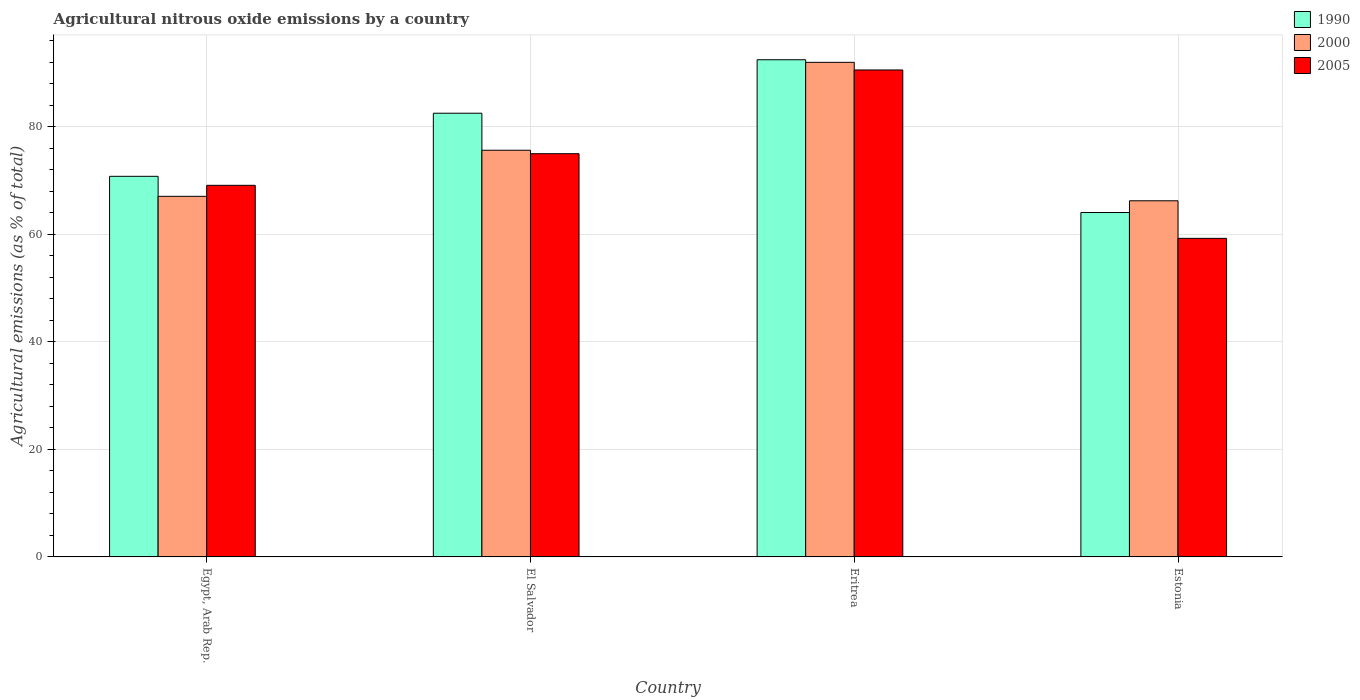How many groups of bars are there?
Provide a short and direct response. 4. Are the number of bars per tick equal to the number of legend labels?
Make the answer very short. Yes. Are the number of bars on each tick of the X-axis equal?
Offer a very short reply. Yes. How many bars are there on the 1st tick from the right?
Offer a very short reply. 3. What is the label of the 4th group of bars from the left?
Make the answer very short. Estonia. What is the amount of agricultural nitrous oxide emitted in 1990 in Estonia?
Your response must be concise. 64.06. Across all countries, what is the maximum amount of agricultural nitrous oxide emitted in 2005?
Ensure brevity in your answer.  90.57. Across all countries, what is the minimum amount of agricultural nitrous oxide emitted in 1990?
Keep it short and to the point. 64.06. In which country was the amount of agricultural nitrous oxide emitted in 2000 maximum?
Give a very brief answer. Eritrea. In which country was the amount of agricultural nitrous oxide emitted in 1990 minimum?
Ensure brevity in your answer.  Estonia. What is the total amount of agricultural nitrous oxide emitted in 2000 in the graph?
Make the answer very short. 300.93. What is the difference between the amount of agricultural nitrous oxide emitted in 1990 in Eritrea and that in Estonia?
Give a very brief answer. 28.41. What is the difference between the amount of agricultural nitrous oxide emitted in 2000 in Eritrea and the amount of agricultural nitrous oxide emitted in 1990 in Estonia?
Your answer should be compact. 27.93. What is the average amount of agricultural nitrous oxide emitted in 2000 per country?
Keep it short and to the point. 75.23. What is the difference between the amount of agricultural nitrous oxide emitted of/in 2000 and amount of agricultural nitrous oxide emitted of/in 1990 in Estonia?
Offer a very short reply. 2.18. In how many countries, is the amount of agricultural nitrous oxide emitted in 1990 greater than 56 %?
Offer a terse response. 4. What is the ratio of the amount of agricultural nitrous oxide emitted in 2005 in Egypt, Arab Rep. to that in Estonia?
Your response must be concise. 1.17. Is the difference between the amount of agricultural nitrous oxide emitted in 2000 in Egypt, Arab Rep. and Estonia greater than the difference between the amount of agricultural nitrous oxide emitted in 1990 in Egypt, Arab Rep. and Estonia?
Give a very brief answer. No. What is the difference between the highest and the second highest amount of agricultural nitrous oxide emitted in 1990?
Ensure brevity in your answer.  -9.95. What is the difference between the highest and the lowest amount of agricultural nitrous oxide emitted in 1990?
Offer a terse response. 28.41. What does the 2nd bar from the right in Eritrea represents?
Make the answer very short. 2000. How many bars are there?
Make the answer very short. 12. Are all the bars in the graph horizontal?
Give a very brief answer. No. How many countries are there in the graph?
Your response must be concise. 4. What is the difference between two consecutive major ticks on the Y-axis?
Keep it short and to the point. 20. How many legend labels are there?
Your answer should be very brief. 3. What is the title of the graph?
Your response must be concise. Agricultural nitrous oxide emissions by a country. What is the label or title of the X-axis?
Keep it short and to the point. Country. What is the label or title of the Y-axis?
Keep it short and to the point. Agricultural emissions (as % of total). What is the Agricultural emissions (as % of total) in 1990 in Egypt, Arab Rep.?
Give a very brief answer. 70.79. What is the Agricultural emissions (as % of total) of 2000 in Egypt, Arab Rep.?
Make the answer very short. 67.07. What is the Agricultural emissions (as % of total) in 2005 in Egypt, Arab Rep.?
Ensure brevity in your answer.  69.11. What is the Agricultural emissions (as % of total) in 1990 in El Salvador?
Give a very brief answer. 82.52. What is the Agricultural emissions (as % of total) of 2000 in El Salvador?
Ensure brevity in your answer.  75.64. What is the Agricultural emissions (as % of total) of 2005 in El Salvador?
Provide a short and direct response. 74.99. What is the Agricultural emissions (as % of total) in 1990 in Eritrea?
Keep it short and to the point. 92.47. What is the Agricultural emissions (as % of total) of 2000 in Eritrea?
Offer a terse response. 91.99. What is the Agricultural emissions (as % of total) of 2005 in Eritrea?
Provide a succinct answer. 90.57. What is the Agricultural emissions (as % of total) in 1990 in Estonia?
Give a very brief answer. 64.06. What is the Agricultural emissions (as % of total) in 2000 in Estonia?
Ensure brevity in your answer.  66.24. What is the Agricultural emissions (as % of total) of 2005 in Estonia?
Your answer should be compact. 59.25. Across all countries, what is the maximum Agricultural emissions (as % of total) in 1990?
Give a very brief answer. 92.47. Across all countries, what is the maximum Agricultural emissions (as % of total) of 2000?
Your answer should be compact. 91.99. Across all countries, what is the maximum Agricultural emissions (as % of total) of 2005?
Provide a succinct answer. 90.57. Across all countries, what is the minimum Agricultural emissions (as % of total) in 1990?
Provide a short and direct response. 64.06. Across all countries, what is the minimum Agricultural emissions (as % of total) of 2000?
Make the answer very short. 66.24. Across all countries, what is the minimum Agricultural emissions (as % of total) of 2005?
Ensure brevity in your answer.  59.25. What is the total Agricultural emissions (as % of total) in 1990 in the graph?
Provide a short and direct response. 309.84. What is the total Agricultural emissions (as % of total) in 2000 in the graph?
Provide a succinct answer. 300.93. What is the total Agricultural emissions (as % of total) of 2005 in the graph?
Provide a short and direct response. 293.93. What is the difference between the Agricultural emissions (as % of total) of 1990 in Egypt, Arab Rep. and that in El Salvador?
Your answer should be very brief. -11.73. What is the difference between the Agricultural emissions (as % of total) in 2000 in Egypt, Arab Rep. and that in El Salvador?
Provide a succinct answer. -8.57. What is the difference between the Agricultural emissions (as % of total) in 2005 in Egypt, Arab Rep. and that in El Salvador?
Your response must be concise. -5.88. What is the difference between the Agricultural emissions (as % of total) of 1990 in Egypt, Arab Rep. and that in Eritrea?
Your response must be concise. -21.68. What is the difference between the Agricultural emissions (as % of total) of 2000 in Egypt, Arab Rep. and that in Eritrea?
Your response must be concise. -24.92. What is the difference between the Agricultural emissions (as % of total) of 2005 in Egypt, Arab Rep. and that in Eritrea?
Offer a terse response. -21.46. What is the difference between the Agricultural emissions (as % of total) in 1990 in Egypt, Arab Rep. and that in Estonia?
Your answer should be compact. 6.73. What is the difference between the Agricultural emissions (as % of total) of 2000 in Egypt, Arab Rep. and that in Estonia?
Ensure brevity in your answer.  0.83. What is the difference between the Agricultural emissions (as % of total) of 2005 in Egypt, Arab Rep. and that in Estonia?
Your response must be concise. 9.86. What is the difference between the Agricultural emissions (as % of total) of 1990 in El Salvador and that in Eritrea?
Keep it short and to the point. -9.95. What is the difference between the Agricultural emissions (as % of total) in 2000 in El Salvador and that in Eritrea?
Provide a short and direct response. -16.35. What is the difference between the Agricultural emissions (as % of total) of 2005 in El Salvador and that in Eritrea?
Your answer should be very brief. -15.57. What is the difference between the Agricultural emissions (as % of total) in 1990 in El Salvador and that in Estonia?
Give a very brief answer. 18.47. What is the difference between the Agricultural emissions (as % of total) of 2000 in El Salvador and that in Estonia?
Provide a short and direct response. 9.4. What is the difference between the Agricultural emissions (as % of total) in 2005 in El Salvador and that in Estonia?
Ensure brevity in your answer.  15.74. What is the difference between the Agricultural emissions (as % of total) in 1990 in Eritrea and that in Estonia?
Give a very brief answer. 28.41. What is the difference between the Agricultural emissions (as % of total) in 2000 in Eritrea and that in Estonia?
Offer a very short reply. 25.75. What is the difference between the Agricultural emissions (as % of total) in 2005 in Eritrea and that in Estonia?
Your answer should be compact. 31.32. What is the difference between the Agricultural emissions (as % of total) of 1990 in Egypt, Arab Rep. and the Agricultural emissions (as % of total) of 2000 in El Salvador?
Your answer should be very brief. -4.85. What is the difference between the Agricultural emissions (as % of total) in 1990 in Egypt, Arab Rep. and the Agricultural emissions (as % of total) in 2005 in El Salvador?
Your answer should be compact. -4.21. What is the difference between the Agricultural emissions (as % of total) in 2000 in Egypt, Arab Rep. and the Agricultural emissions (as % of total) in 2005 in El Salvador?
Ensure brevity in your answer.  -7.93. What is the difference between the Agricultural emissions (as % of total) in 1990 in Egypt, Arab Rep. and the Agricultural emissions (as % of total) in 2000 in Eritrea?
Offer a terse response. -21.2. What is the difference between the Agricultural emissions (as % of total) in 1990 in Egypt, Arab Rep. and the Agricultural emissions (as % of total) in 2005 in Eritrea?
Your answer should be very brief. -19.78. What is the difference between the Agricultural emissions (as % of total) of 2000 in Egypt, Arab Rep. and the Agricultural emissions (as % of total) of 2005 in Eritrea?
Keep it short and to the point. -23.5. What is the difference between the Agricultural emissions (as % of total) in 1990 in Egypt, Arab Rep. and the Agricultural emissions (as % of total) in 2000 in Estonia?
Your answer should be compact. 4.55. What is the difference between the Agricultural emissions (as % of total) of 1990 in Egypt, Arab Rep. and the Agricultural emissions (as % of total) of 2005 in Estonia?
Ensure brevity in your answer.  11.54. What is the difference between the Agricultural emissions (as % of total) in 2000 in Egypt, Arab Rep. and the Agricultural emissions (as % of total) in 2005 in Estonia?
Your response must be concise. 7.82. What is the difference between the Agricultural emissions (as % of total) of 1990 in El Salvador and the Agricultural emissions (as % of total) of 2000 in Eritrea?
Offer a terse response. -9.46. What is the difference between the Agricultural emissions (as % of total) in 1990 in El Salvador and the Agricultural emissions (as % of total) in 2005 in Eritrea?
Offer a very short reply. -8.05. What is the difference between the Agricultural emissions (as % of total) of 2000 in El Salvador and the Agricultural emissions (as % of total) of 2005 in Eritrea?
Provide a short and direct response. -14.93. What is the difference between the Agricultural emissions (as % of total) in 1990 in El Salvador and the Agricultural emissions (as % of total) in 2000 in Estonia?
Your answer should be very brief. 16.29. What is the difference between the Agricultural emissions (as % of total) of 1990 in El Salvador and the Agricultural emissions (as % of total) of 2005 in Estonia?
Your answer should be very brief. 23.27. What is the difference between the Agricultural emissions (as % of total) of 2000 in El Salvador and the Agricultural emissions (as % of total) of 2005 in Estonia?
Ensure brevity in your answer.  16.39. What is the difference between the Agricultural emissions (as % of total) of 1990 in Eritrea and the Agricultural emissions (as % of total) of 2000 in Estonia?
Your response must be concise. 26.23. What is the difference between the Agricultural emissions (as % of total) of 1990 in Eritrea and the Agricultural emissions (as % of total) of 2005 in Estonia?
Keep it short and to the point. 33.22. What is the difference between the Agricultural emissions (as % of total) in 2000 in Eritrea and the Agricultural emissions (as % of total) in 2005 in Estonia?
Your answer should be compact. 32.74. What is the average Agricultural emissions (as % of total) of 1990 per country?
Offer a very short reply. 77.46. What is the average Agricultural emissions (as % of total) of 2000 per country?
Make the answer very short. 75.23. What is the average Agricultural emissions (as % of total) in 2005 per country?
Keep it short and to the point. 73.48. What is the difference between the Agricultural emissions (as % of total) in 1990 and Agricultural emissions (as % of total) in 2000 in Egypt, Arab Rep.?
Your response must be concise. 3.72. What is the difference between the Agricultural emissions (as % of total) of 1990 and Agricultural emissions (as % of total) of 2005 in Egypt, Arab Rep.?
Your answer should be compact. 1.68. What is the difference between the Agricultural emissions (as % of total) of 2000 and Agricultural emissions (as % of total) of 2005 in Egypt, Arab Rep.?
Offer a terse response. -2.05. What is the difference between the Agricultural emissions (as % of total) of 1990 and Agricultural emissions (as % of total) of 2000 in El Salvador?
Ensure brevity in your answer.  6.88. What is the difference between the Agricultural emissions (as % of total) in 1990 and Agricultural emissions (as % of total) in 2005 in El Salvador?
Ensure brevity in your answer.  7.53. What is the difference between the Agricultural emissions (as % of total) in 2000 and Agricultural emissions (as % of total) in 2005 in El Salvador?
Your answer should be very brief. 0.64. What is the difference between the Agricultural emissions (as % of total) of 1990 and Agricultural emissions (as % of total) of 2000 in Eritrea?
Your answer should be very brief. 0.48. What is the difference between the Agricultural emissions (as % of total) in 1990 and Agricultural emissions (as % of total) in 2005 in Eritrea?
Ensure brevity in your answer.  1.9. What is the difference between the Agricultural emissions (as % of total) of 2000 and Agricultural emissions (as % of total) of 2005 in Eritrea?
Keep it short and to the point. 1.42. What is the difference between the Agricultural emissions (as % of total) of 1990 and Agricultural emissions (as % of total) of 2000 in Estonia?
Offer a very short reply. -2.18. What is the difference between the Agricultural emissions (as % of total) of 1990 and Agricultural emissions (as % of total) of 2005 in Estonia?
Your answer should be very brief. 4.8. What is the difference between the Agricultural emissions (as % of total) of 2000 and Agricultural emissions (as % of total) of 2005 in Estonia?
Keep it short and to the point. 6.98. What is the ratio of the Agricultural emissions (as % of total) in 1990 in Egypt, Arab Rep. to that in El Salvador?
Offer a very short reply. 0.86. What is the ratio of the Agricultural emissions (as % of total) in 2000 in Egypt, Arab Rep. to that in El Salvador?
Offer a terse response. 0.89. What is the ratio of the Agricultural emissions (as % of total) in 2005 in Egypt, Arab Rep. to that in El Salvador?
Provide a short and direct response. 0.92. What is the ratio of the Agricultural emissions (as % of total) in 1990 in Egypt, Arab Rep. to that in Eritrea?
Your answer should be very brief. 0.77. What is the ratio of the Agricultural emissions (as % of total) in 2000 in Egypt, Arab Rep. to that in Eritrea?
Your answer should be very brief. 0.73. What is the ratio of the Agricultural emissions (as % of total) in 2005 in Egypt, Arab Rep. to that in Eritrea?
Offer a terse response. 0.76. What is the ratio of the Agricultural emissions (as % of total) in 1990 in Egypt, Arab Rep. to that in Estonia?
Make the answer very short. 1.11. What is the ratio of the Agricultural emissions (as % of total) of 2000 in Egypt, Arab Rep. to that in Estonia?
Your answer should be compact. 1.01. What is the ratio of the Agricultural emissions (as % of total) in 2005 in Egypt, Arab Rep. to that in Estonia?
Keep it short and to the point. 1.17. What is the ratio of the Agricultural emissions (as % of total) in 1990 in El Salvador to that in Eritrea?
Offer a terse response. 0.89. What is the ratio of the Agricultural emissions (as % of total) of 2000 in El Salvador to that in Eritrea?
Provide a succinct answer. 0.82. What is the ratio of the Agricultural emissions (as % of total) in 2005 in El Salvador to that in Eritrea?
Make the answer very short. 0.83. What is the ratio of the Agricultural emissions (as % of total) in 1990 in El Salvador to that in Estonia?
Provide a succinct answer. 1.29. What is the ratio of the Agricultural emissions (as % of total) in 2000 in El Salvador to that in Estonia?
Provide a succinct answer. 1.14. What is the ratio of the Agricultural emissions (as % of total) in 2005 in El Salvador to that in Estonia?
Your response must be concise. 1.27. What is the ratio of the Agricultural emissions (as % of total) in 1990 in Eritrea to that in Estonia?
Offer a terse response. 1.44. What is the ratio of the Agricultural emissions (as % of total) of 2000 in Eritrea to that in Estonia?
Offer a very short reply. 1.39. What is the ratio of the Agricultural emissions (as % of total) of 2005 in Eritrea to that in Estonia?
Your response must be concise. 1.53. What is the difference between the highest and the second highest Agricultural emissions (as % of total) in 1990?
Ensure brevity in your answer.  9.95. What is the difference between the highest and the second highest Agricultural emissions (as % of total) in 2000?
Ensure brevity in your answer.  16.35. What is the difference between the highest and the second highest Agricultural emissions (as % of total) in 2005?
Provide a succinct answer. 15.57. What is the difference between the highest and the lowest Agricultural emissions (as % of total) of 1990?
Ensure brevity in your answer.  28.41. What is the difference between the highest and the lowest Agricultural emissions (as % of total) of 2000?
Offer a very short reply. 25.75. What is the difference between the highest and the lowest Agricultural emissions (as % of total) in 2005?
Keep it short and to the point. 31.32. 